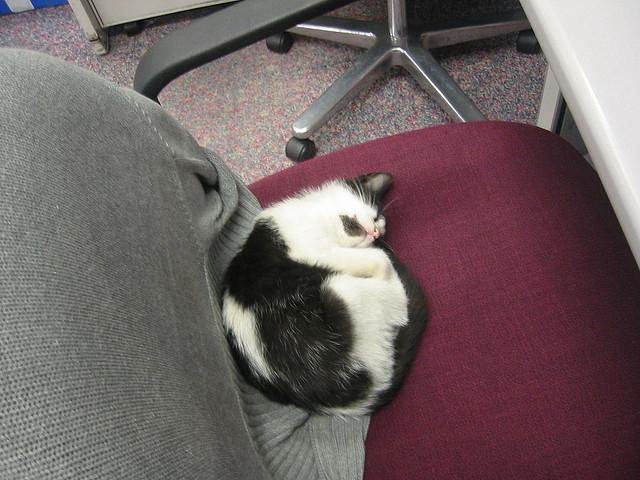Did the cat buy the chair?
Be succinct. No. Is this cat awake?
Short answer required. No. Where is the cat sleeping?
Concise answer only. Chair. 